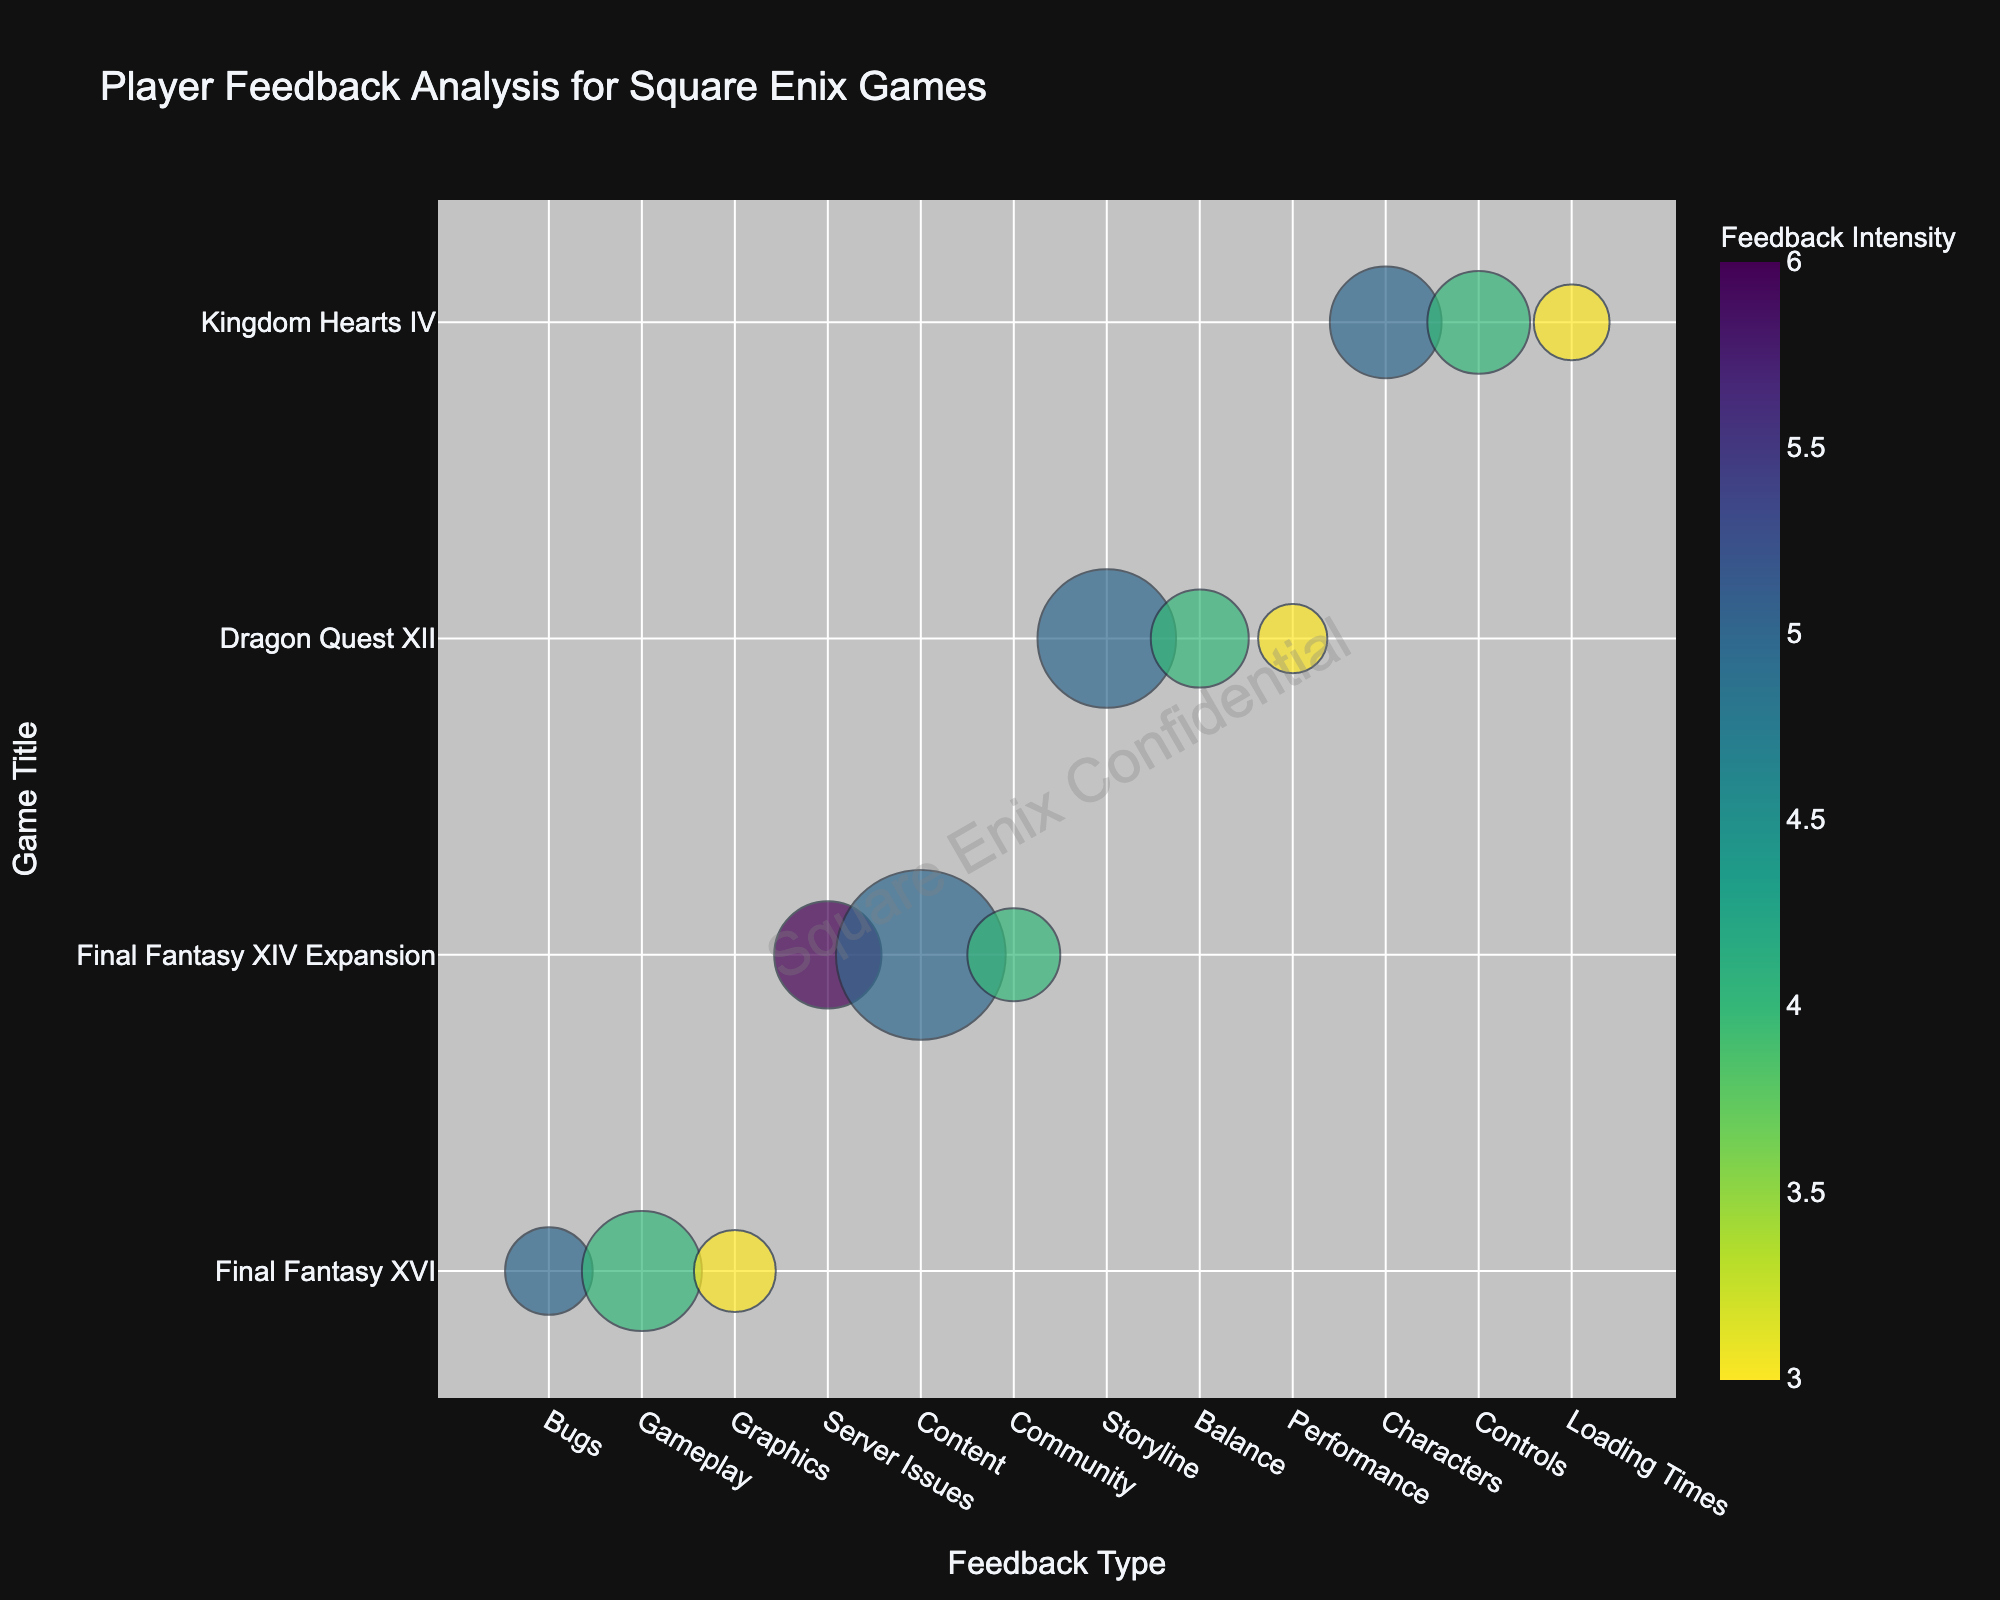How many feedback types are there for Final Fantasy XVI? The chart shows different bubbles per feedback type and game title. For Final Fantasy XVI, there are bubbles for "Bugs," "Gameplay," and "Graphics."
Answer: 3 Which game title has the highest feedback frequency overall? To determine the highest feedback frequency, we need to identify the largest bubble. The "Content" bubble for "Final Fantasy XIV Expansion" is the largest.
Answer: Final Fantasy XIV Expansion What is the intensity level for Server Issues feedback on the Final Fantasy XIV Expansion? Locate the "Server Issues" bubble under "Final Fantasy XIV Expansion" and refer to its color intensity, which is marked by 6.
Answer: 6 Compare the frequency of Graphics feedback for Final Fantasy XVI and Performance feedback for Dragon Quest XII. Which one is higher? By comparing the size of the "Graphics" bubble for Final Fantasy XVI (70) to the "Performance" bubble for Dragon Quest XII (50), the former is higher.
Answer: Graphics for Final Fantasy XVI What feedback type has the highest intensity level, and for which game? We need to scan the color bar for the highest intensity level, which is 6. The "Server Issues" feedback for "Final Fantasy XIV Expansion" matches this intensity.
Answer: Server Issues for Final Fantasy XIV Expansion Which game has received the most feedback about storyline issues? Locate the "Storyline" feedback on the y-axis and identify the corresponding bubble. Dragon Quest XII has a frequency of 200 for this feedback type.
Answer: Dragon Quest XII Calculate the total frequency of feedbacks related to Gameplay for Final Fantasy XVI and Controls for Kingdom Hearts IV. Sum the frequencies of both bubbles: 150 (Gameplay for Final Fantasy XVI) + 110 (Controls for Kingdom Hearts IV).
Answer: 260 Among the feedback for Bugs in Final Fantasy XVI and Balance in Dragon Quest XII, which has a higher feedback intensity? Compare the intensities by color; "Bugs" for Final Fantasy XVI is 5 and "Balance" for Dragon Quest XII is 4. The "Bugs" feedback has a higher intensity.
Answer: Bugs for Final Fantasy XVI What type of feedback does Kingdom Hearts IV receive with the lowest frequency? Look at Kingdom Hearts IV and locate the smallest bubble, which is "Loading Times" with a frequency of 60.
Answer: Loading Times 